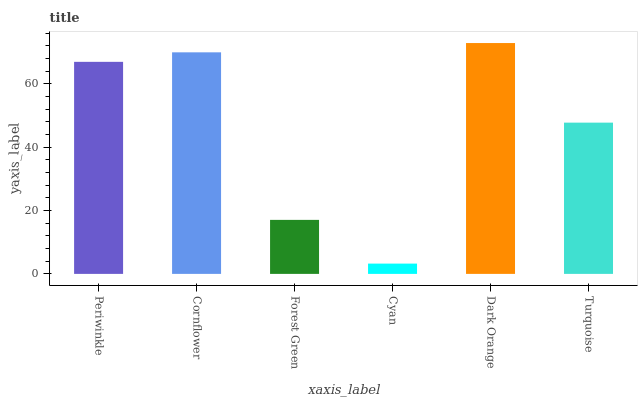Is Cyan the minimum?
Answer yes or no. Yes. Is Dark Orange the maximum?
Answer yes or no. Yes. Is Cornflower the minimum?
Answer yes or no. No. Is Cornflower the maximum?
Answer yes or no. No. Is Cornflower greater than Periwinkle?
Answer yes or no. Yes. Is Periwinkle less than Cornflower?
Answer yes or no. Yes. Is Periwinkle greater than Cornflower?
Answer yes or no. No. Is Cornflower less than Periwinkle?
Answer yes or no. No. Is Periwinkle the high median?
Answer yes or no. Yes. Is Turquoise the low median?
Answer yes or no. Yes. Is Forest Green the high median?
Answer yes or no. No. Is Cyan the low median?
Answer yes or no. No. 